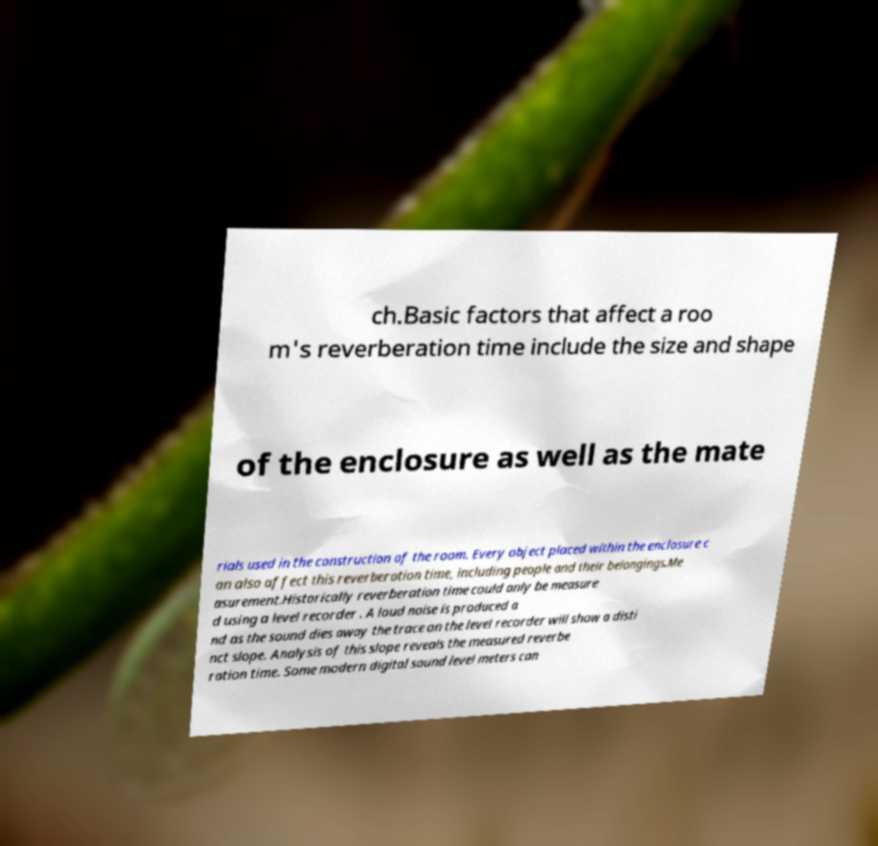There's text embedded in this image that I need extracted. Can you transcribe it verbatim? ch.Basic factors that affect a roo m's reverberation time include the size and shape of the enclosure as well as the mate rials used in the construction of the room. Every object placed within the enclosure c an also affect this reverberation time, including people and their belongings.Me asurement.Historically reverberation time could only be measure d using a level recorder . A loud noise is produced a nd as the sound dies away the trace on the level recorder will show a disti nct slope. Analysis of this slope reveals the measured reverbe ration time. Some modern digital sound level meters can 